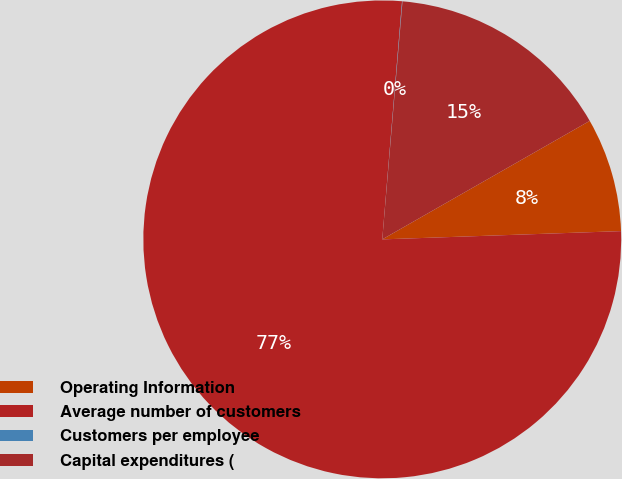<chart> <loc_0><loc_0><loc_500><loc_500><pie_chart><fcel>Operating Information<fcel>Average number of customers<fcel>Customers per employee<fcel>Capital expenditures (<nl><fcel>7.71%<fcel>76.87%<fcel>0.03%<fcel>15.39%<nl></chart> 